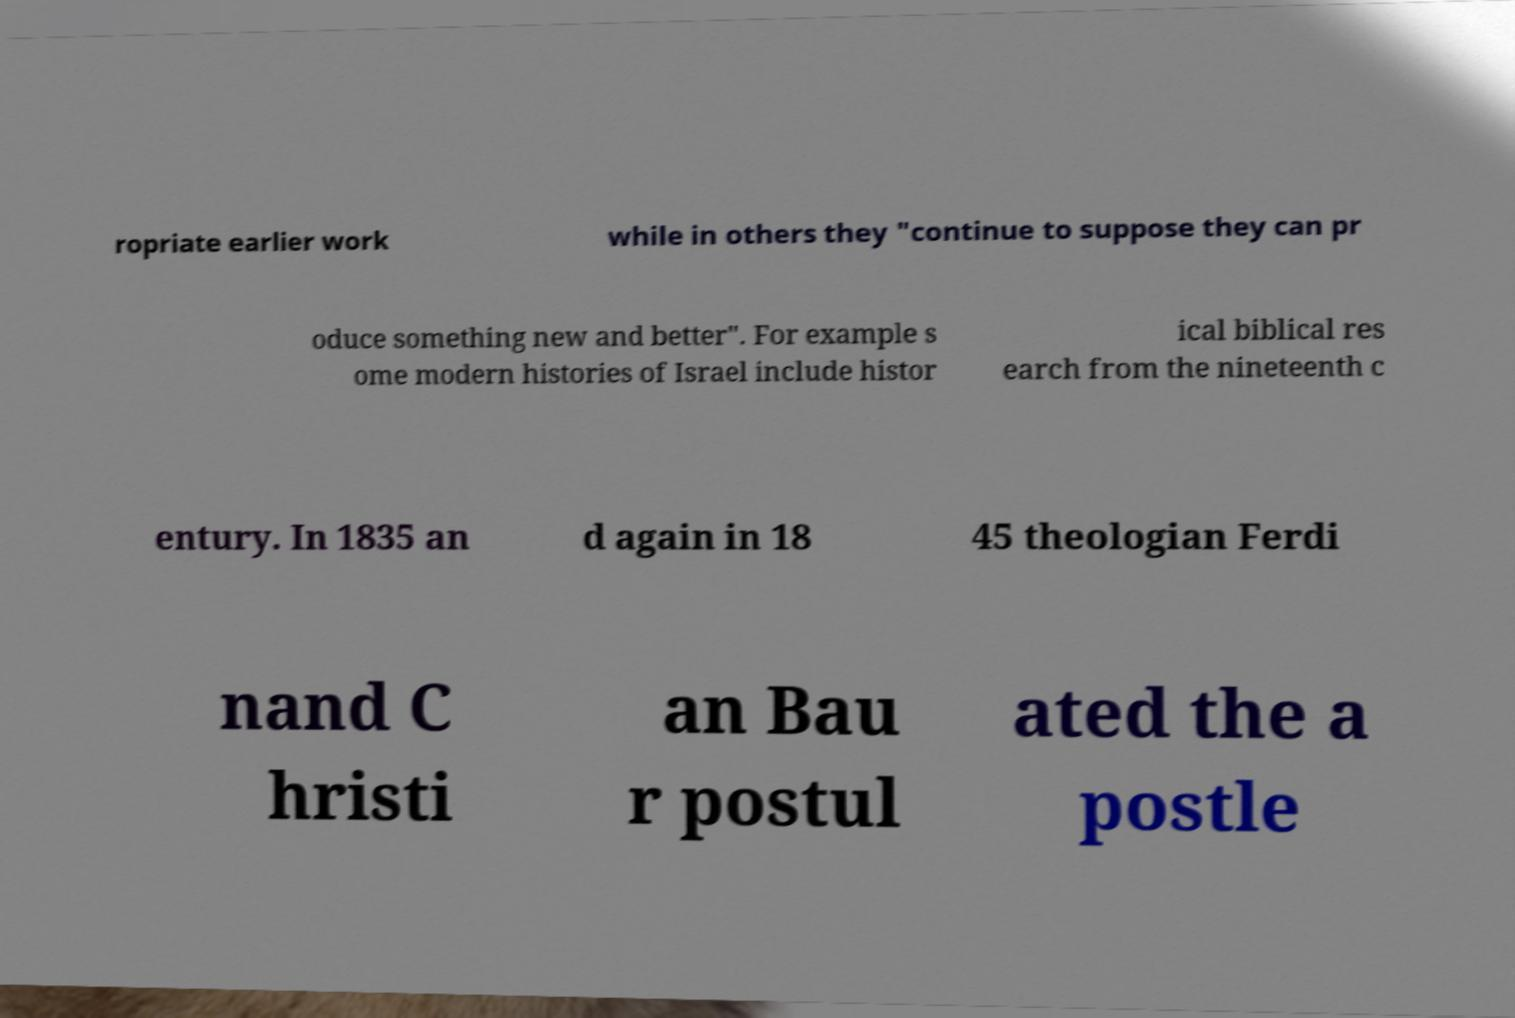I need the written content from this picture converted into text. Can you do that? ropriate earlier work while in others they "continue to suppose they can pr oduce something new and better". For example s ome modern histories of Israel include histor ical biblical res earch from the nineteenth c entury. In 1835 an d again in 18 45 theologian Ferdi nand C hristi an Bau r postul ated the a postle 